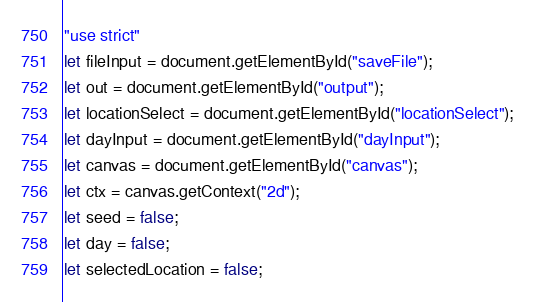Convert code to text. <code><loc_0><loc_0><loc_500><loc_500><_JavaScript_>"use strict"
let fileInput = document.getElementById("saveFile");
let out = document.getElementById("output");
let locationSelect = document.getElementById("locationSelect");
let dayInput = document.getElementById("dayInput");
let canvas = document.getElementById("canvas");
let ctx = canvas.getContext("2d");
let seed = false;
let day = false;
let selectedLocation = false;</code> 